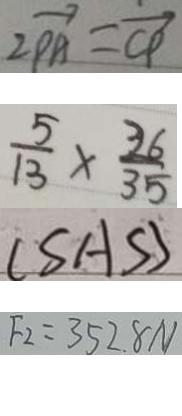<formula> <loc_0><loc_0><loc_500><loc_500>2 \overrightarrow { P A } = \overrightarrow { C P } 
 \frac { 5 } { 1 3 } \times \frac { 3 6 } { 3 5 } 
 ( S A S ) 
 F _ { 2 } = 3 5 2 . 8 N</formula> 